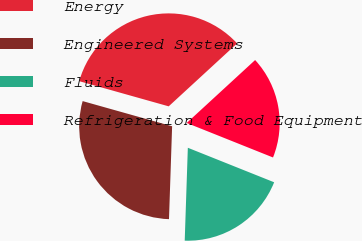Convert chart to OTSL. <chart><loc_0><loc_0><loc_500><loc_500><pie_chart><fcel>Energy<fcel>Engineered Systems<fcel>Fluids<fcel>Refrigeration & Food Equipment<nl><fcel>33.8%<fcel>28.83%<fcel>19.48%<fcel>17.89%<nl></chart> 